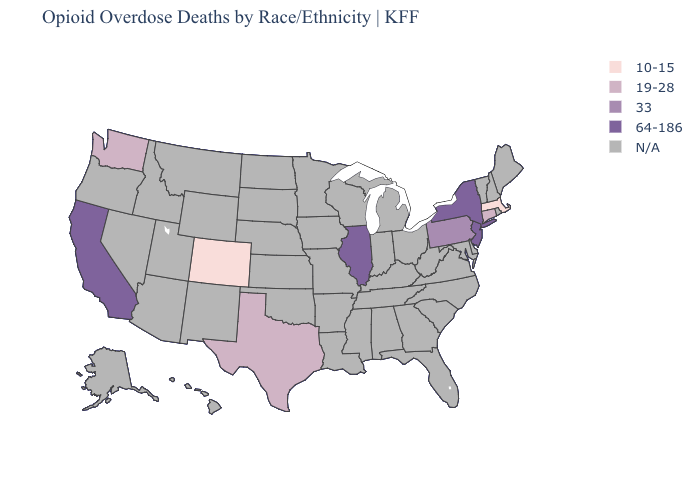Name the states that have a value in the range 33?
Give a very brief answer. Pennsylvania. What is the value of New Mexico?
Quick response, please. N/A. What is the lowest value in the USA?
Quick response, please. 10-15. Does Pennsylvania have the lowest value in the Northeast?
Concise answer only. No. Name the states that have a value in the range 33?
Quick response, please. Pennsylvania. Which states have the highest value in the USA?
Give a very brief answer. California, Illinois, New Jersey, New York. What is the highest value in the USA?
Concise answer only. 64-186. What is the value of West Virginia?
Quick response, please. N/A. What is the lowest value in states that border Louisiana?
Answer briefly. 19-28. What is the value of Tennessee?
Short answer required. N/A. 